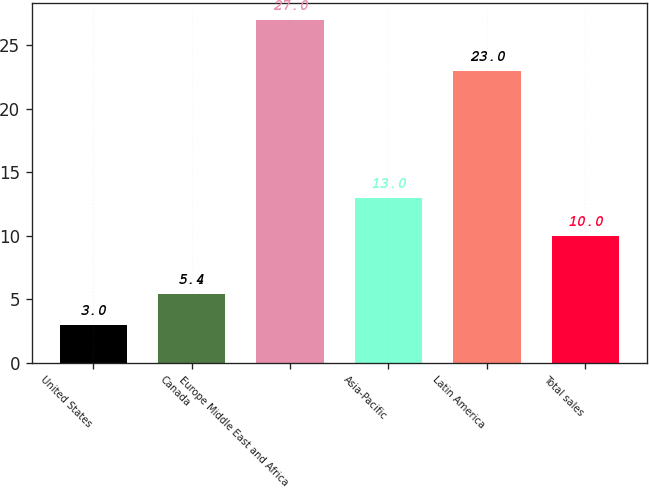Convert chart. <chart><loc_0><loc_0><loc_500><loc_500><bar_chart><fcel>United States<fcel>Canada<fcel>Europe Middle East and Africa<fcel>Asia-Pacific<fcel>Latin America<fcel>Total sales<nl><fcel>3<fcel>5.4<fcel>27<fcel>13<fcel>23<fcel>10<nl></chart> 